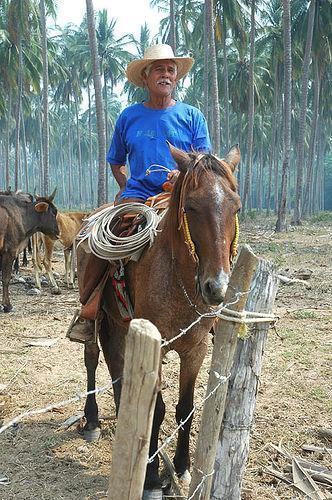How many cows can be seen?
Give a very brief answer. 2. 